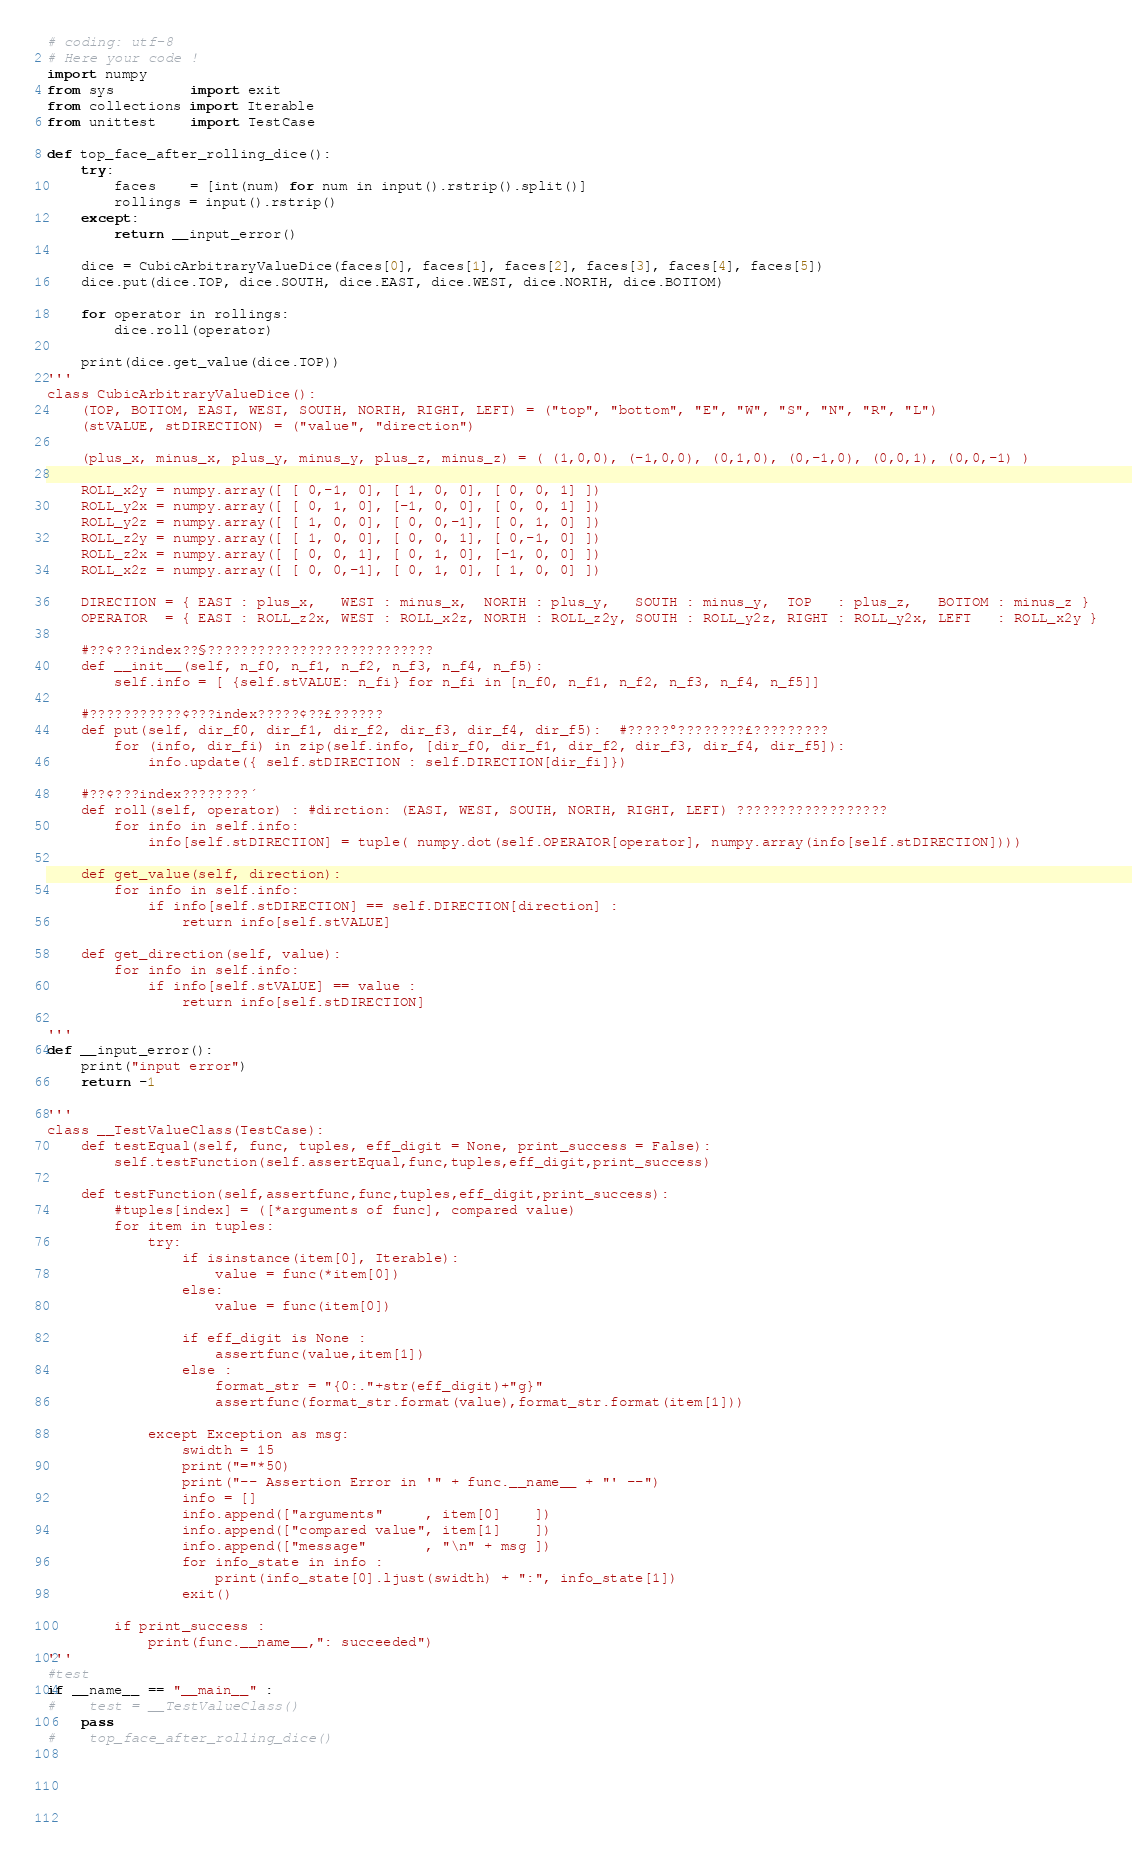Convert code to text. <code><loc_0><loc_0><loc_500><loc_500><_Python_># coding: utf-8
# Here your code !
import numpy
from sys         import exit
from collections import Iterable
from unittest    import TestCase

def top_face_after_rolling_dice():
    try:
        faces    = [int(num) for num in input().rstrip().split()]
        rollings = input().rstrip()
    except:
        return __input_error()

    dice = CubicArbitraryValueDice(faces[0], faces[1], faces[2], faces[3], faces[4], faces[5])
    dice.put(dice.TOP, dice.SOUTH, dice.EAST, dice.WEST, dice.NORTH, dice.BOTTOM)
    
    for operator in rollings:
        dice.roll(operator)

    print(dice.get_value(dice.TOP))
'''
class CubicArbitraryValueDice():
    (TOP, BOTTOM, EAST, WEST, SOUTH, NORTH, RIGHT, LEFT) = ("top", "bottom", "E", "W", "S", "N", "R", "L")
    (stVALUE, stDIRECTION) = ("value", "direction")

    (plus_x, minus_x, plus_y, minus_y, plus_z, minus_z) = ( (1,0,0), (-1,0,0), (0,1,0), (0,-1,0), (0,0,1), (0,0,-1) )

    ROLL_x2y = numpy.array([ [ 0,-1, 0], [ 1, 0, 0], [ 0, 0, 1] ])
    ROLL_y2x = numpy.array([ [ 0, 1, 0], [-1, 0, 0], [ 0, 0, 1] ])
    ROLL_y2z = numpy.array([ [ 1, 0, 0], [ 0, 0,-1], [ 0, 1, 0] ])
    ROLL_z2y = numpy.array([ [ 1, 0, 0], [ 0, 0, 1], [ 0,-1, 0] ])
    ROLL_z2x = numpy.array([ [ 0, 0, 1], [ 0, 1, 0], [-1, 0, 0] ])
    ROLL_x2z = numpy.array([ [ 0, 0,-1], [ 0, 1, 0], [ 1, 0, 0] ])
    
    DIRECTION = { EAST : plus_x,   WEST : minus_x,  NORTH : plus_y,   SOUTH : minus_y,  TOP   : plus_z,   BOTTOM : minus_z }
    OPERATOR  = { EAST : ROLL_z2x, WEST : ROLL_x2z, NORTH : ROLL_z2y, SOUTH : ROLL_y2z, RIGHT : ROLL_y2x, LEFT   : ROLL_x2y }
    
    #??¢???index??§???????????????????????????
    def __init__(self, n_f0, n_f1, n_f2, n_f3, n_f4, n_f5):
        self.info = [ {self.stVALUE: n_fi} for n_fi in [n_f0, n_f1, n_f2, n_f3, n_f4, n_f5]]

    #???????????¢???index?????¢??£??????
    def put(self, dir_f0, dir_f1, dir_f2, dir_f3, dir_f4, dir_f5):  #?????°????????£?????????
        for (info, dir_fi) in zip(self.info, [dir_f0, dir_f1, dir_f2, dir_f3, dir_f4, dir_f5]):
            info.update({ self.stDIRECTION : self.DIRECTION[dir_fi]})

    #??¢???index????????´
    def roll(self, operator) : #dirction: (EAST, WEST, SOUTH, NORTH, RIGHT, LEFT) ??????????????????
        for info in self.info:
            info[self.stDIRECTION] = tuple( numpy.dot(self.OPERATOR[operator], numpy.array(info[self.stDIRECTION])))

    def get_value(self, direction):
        for info in self.info:
            if info[self.stDIRECTION] == self.DIRECTION[direction] :
                return info[self.stVALUE]
    
    def get_direction(self, value):
        for info in self.info:
            if info[self.stVALUE] == value :
                return info[self.stDIRECTION]

'''
def __input_error():
    print("input error")
    return -1

'''
class __TestValueClass(TestCase):
    def testEqual(self, func, tuples, eff_digit = None, print_success = False):
        self.testFunction(self.assertEqual,func,tuples,eff_digit,print_success)
    
    def testFunction(self,assertfunc,func,tuples,eff_digit,print_success):
        #tuples[index] = ([*arguments of func], compared value)
        for item in tuples:
            try:
                if isinstance(item[0], Iterable):
                    value = func(*item[0])
                else:
                    value = func(item[0])
                
                if eff_digit is None :
                    assertfunc(value,item[1])
                else :
                    format_str = "{0:."+str(eff_digit)+"g}"
                    assertfunc(format_str.format(value),format_str.format(item[1]))
                    
            except Exception as msg:
                swidth = 15
                print("="*50)
                print("-- Assertion Error in '" + func.__name__ + "' --")
                info = []
                info.append(["arguments"     , item[0]    ])
                info.append(["compared value", item[1]    ])
                info.append(["message"       , "\n" + msg ])
                for info_state in info :
                    print(info_state[0].ljust(swidth) + ":", info_state[1])
                exit()

        if print_success :
            print(func.__name__,": succeeded")
'''
#test
if __name__ == "__main__" :
#    test = __TestValueClass()
    pass
#    top_face_after_rolling_dice()
    
    
   
    
    </code> 